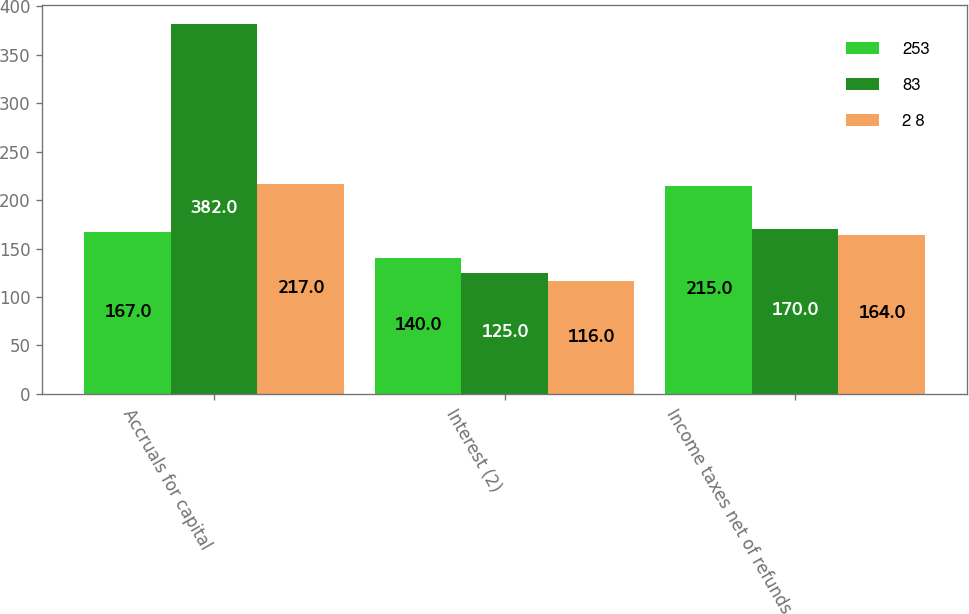Convert chart to OTSL. <chart><loc_0><loc_0><loc_500><loc_500><stacked_bar_chart><ecel><fcel>Accruals for capital<fcel>Interest (2)<fcel>Income taxes net of refunds<nl><fcel>253<fcel>167<fcel>140<fcel>215<nl><fcel>83<fcel>382<fcel>125<fcel>170<nl><fcel>2 8<fcel>217<fcel>116<fcel>164<nl></chart> 